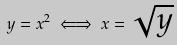<formula> <loc_0><loc_0><loc_500><loc_500>y = x ^ { 2 } \iff x = \sqrt { y }</formula> 